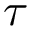<formula> <loc_0><loc_0><loc_500><loc_500>\tau</formula> 